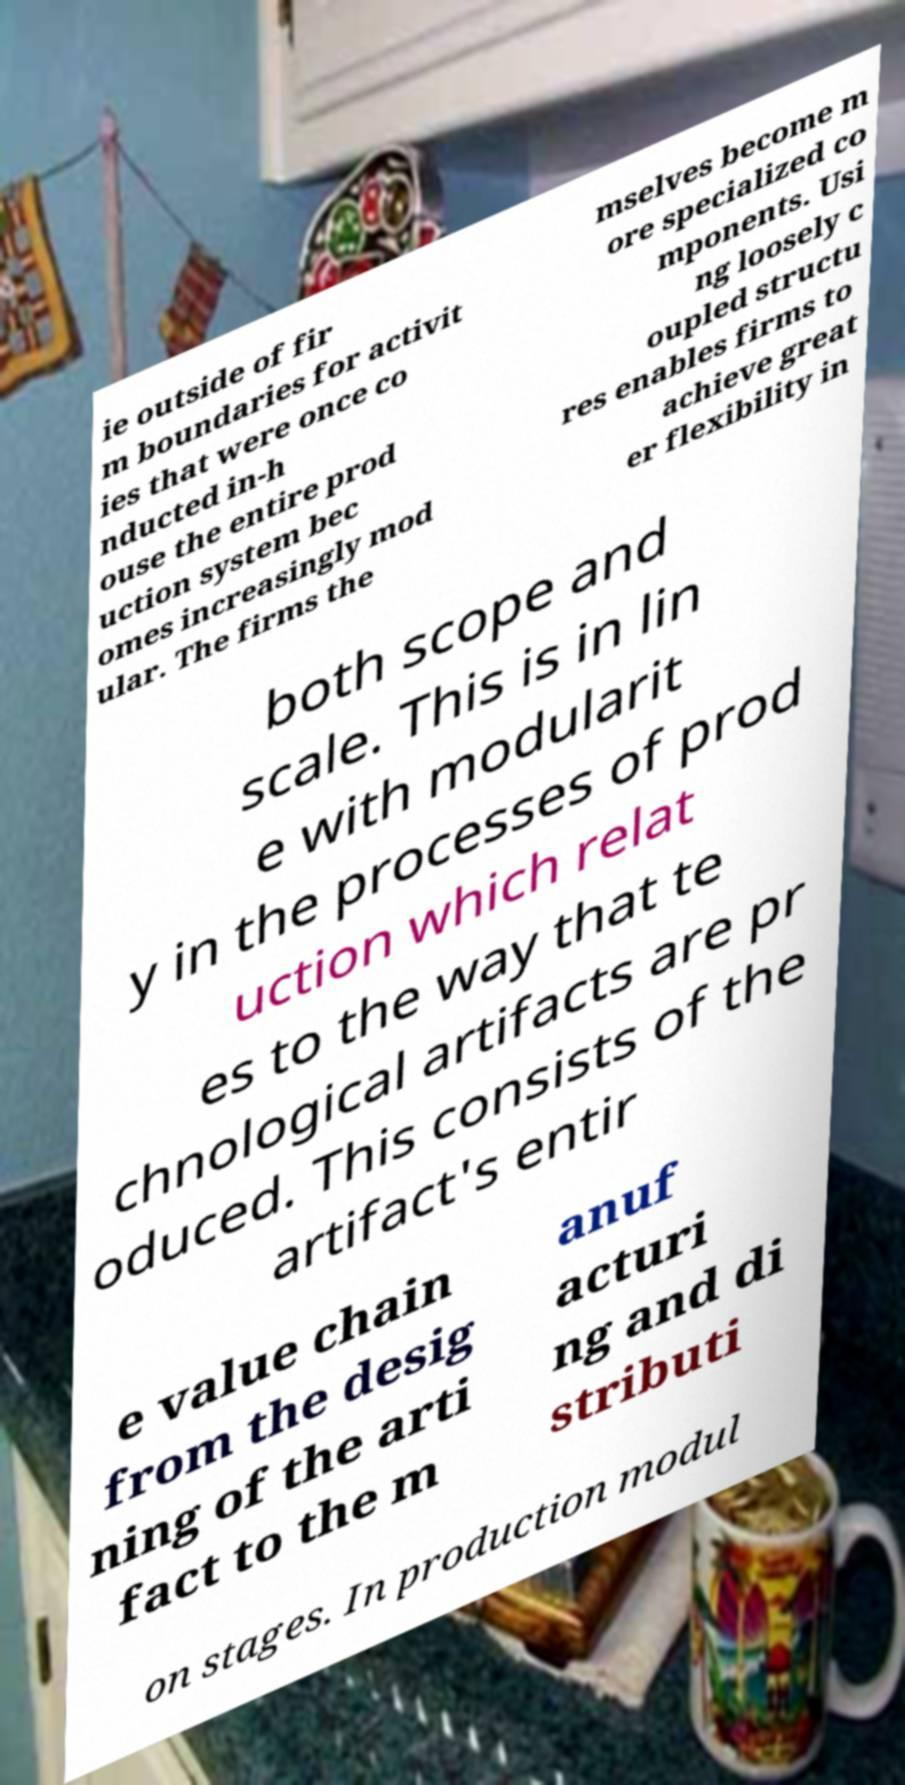Please read and relay the text visible in this image. What does it say? ie outside of fir m boundaries for activit ies that were once co nducted in-h ouse the entire prod uction system bec omes increasingly mod ular. The firms the mselves become m ore specialized co mponents. Usi ng loosely c oupled structu res enables firms to achieve great er flexibility in both scope and scale. This is in lin e with modularit y in the processes of prod uction which relat es to the way that te chnological artifacts are pr oduced. This consists of the artifact's entir e value chain from the desig ning of the arti fact to the m anuf acturi ng and di stributi on stages. In production modul 